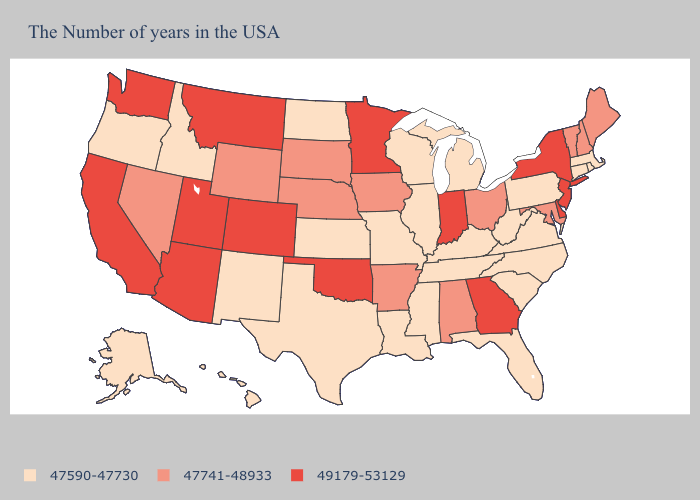Does the first symbol in the legend represent the smallest category?
Keep it brief. Yes. Does Kansas have a lower value than Missouri?
Be succinct. No. What is the value of Kansas?
Give a very brief answer. 47590-47730. What is the value of Texas?
Concise answer only. 47590-47730. Which states hav the highest value in the Northeast?
Concise answer only. New York, New Jersey. Name the states that have a value in the range 47590-47730?
Be succinct. Massachusetts, Rhode Island, Connecticut, Pennsylvania, Virginia, North Carolina, South Carolina, West Virginia, Florida, Michigan, Kentucky, Tennessee, Wisconsin, Illinois, Mississippi, Louisiana, Missouri, Kansas, Texas, North Dakota, New Mexico, Idaho, Oregon, Alaska, Hawaii. What is the value of Massachusetts?
Give a very brief answer. 47590-47730. Does North Dakota have a lower value than Wisconsin?
Concise answer only. No. What is the value of New York?
Concise answer only. 49179-53129. What is the lowest value in states that border Iowa?
Give a very brief answer. 47590-47730. Does Delaware have the highest value in the South?
Be succinct. Yes. What is the highest value in the USA?
Concise answer only. 49179-53129. Does Alabama have the lowest value in the South?
Give a very brief answer. No. What is the highest value in the West ?
Keep it brief. 49179-53129. Among the states that border North Carolina , which have the highest value?
Write a very short answer. Georgia. 